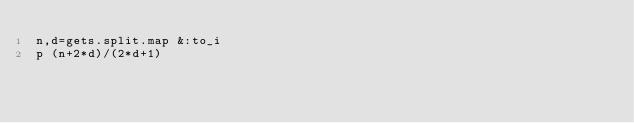<code> <loc_0><loc_0><loc_500><loc_500><_Ruby_>n,d=gets.split.map &:to_i
p (n+2*d)/(2*d+1)</code> 